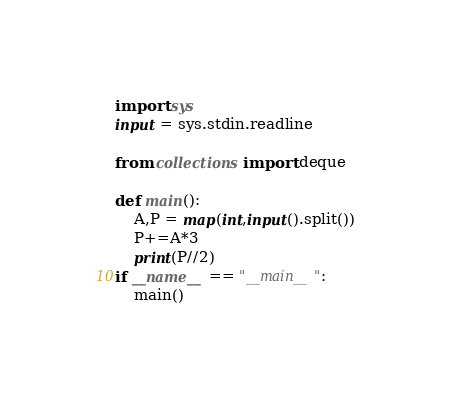Convert code to text. <code><loc_0><loc_0><loc_500><loc_500><_Python_>import sys
input = sys.stdin.readline

from collections import deque

def main(): 
    A,P = map(int,input().split())
    P+=A*3
    print(P//2)
if __name__ == "__main__":
    main()
    </code> 